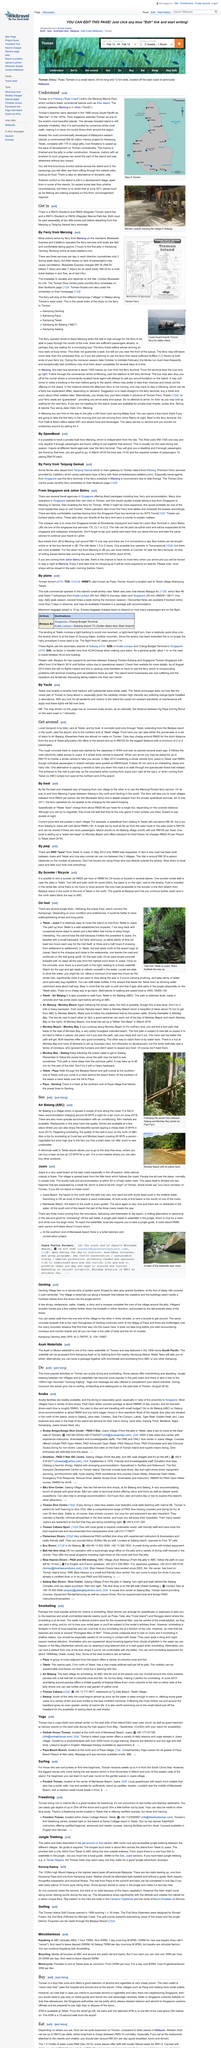Highlight a few significant elements in this photo. A licensed diver typically spends approximately RM90 per dive. The island offers less explored dive sites on its eastern side, renowned for their exceptional macro diving opportunities. These sites include Karang Tohor, Berlabuh, Najoi, Semanjing, and Juara House Reef, which are ideal for discovering an array of marine life and underwater beauty. The average cost of a Padi Open water course is approximately RM990 for a four-day course. 